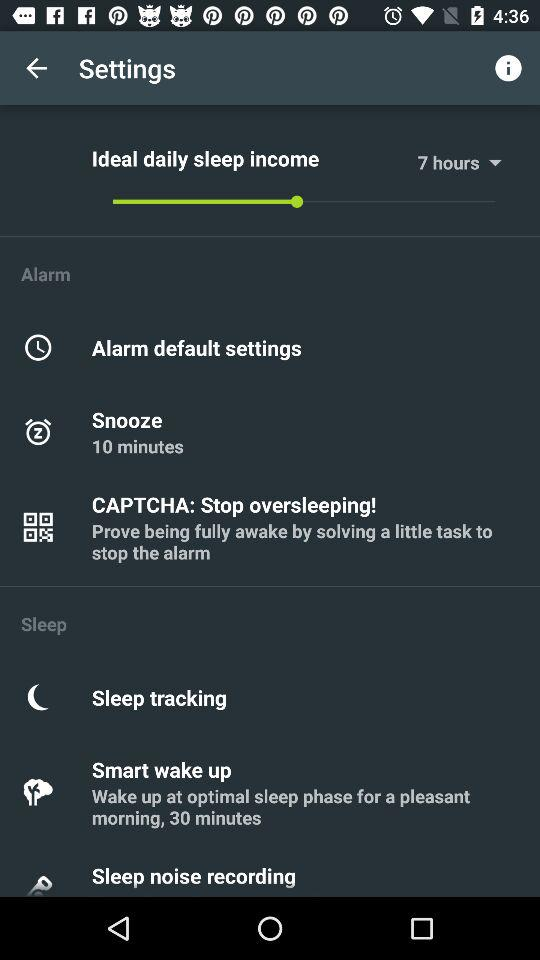How many minutes is the smart wake up option?
Answer the question using a single word or phrase. 30 minutes 